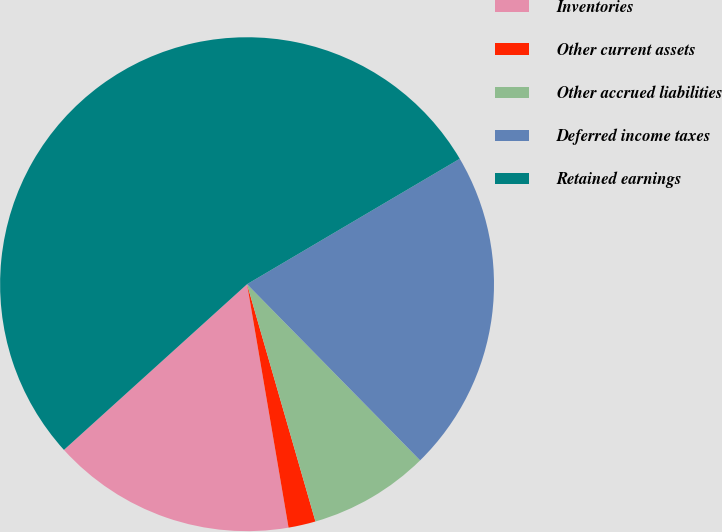Convert chart to OTSL. <chart><loc_0><loc_0><loc_500><loc_500><pie_chart><fcel>Inventories<fcel>Other current assets<fcel>Other accrued liabilities<fcel>Deferred income taxes<fcel>Retained earnings<nl><fcel>15.98%<fcel>1.78%<fcel>7.89%<fcel>21.12%<fcel>53.22%<nl></chart> 